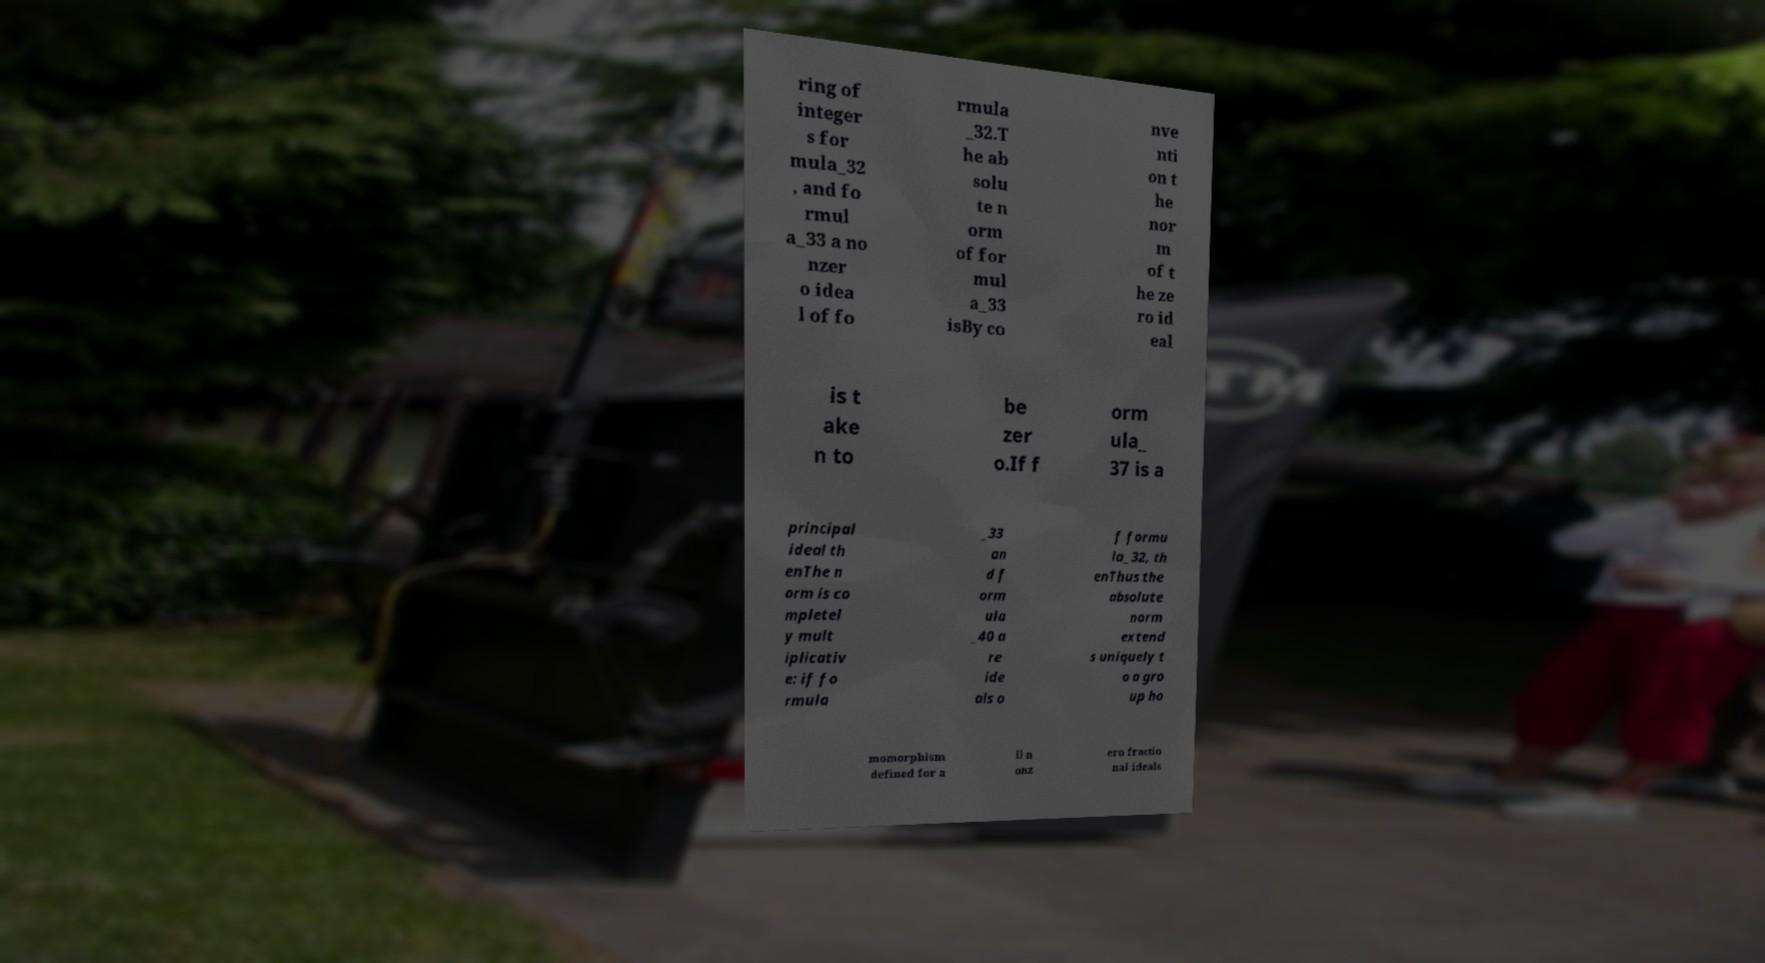Can you accurately transcribe the text from the provided image for me? ring of integer s for mula_32 , and fo rmul a_33 a no nzer o idea l of fo rmula _32.T he ab solu te n orm of for mul a_33 isBy co nve nti on t he nor m of t he ze ro id eal is t ake n to be zer o.If f orm ula_ 37 is a principal ideal th enThe n orm is co mpletel y mult iplicativ e: if fo rmula _33 an d f orm ula _40 a re ide als o f formu la_32, th enThus the absolute norm extend s uniquely t o a gro up ho momorphism defined for a ll n onz ero fractio nal ideals 